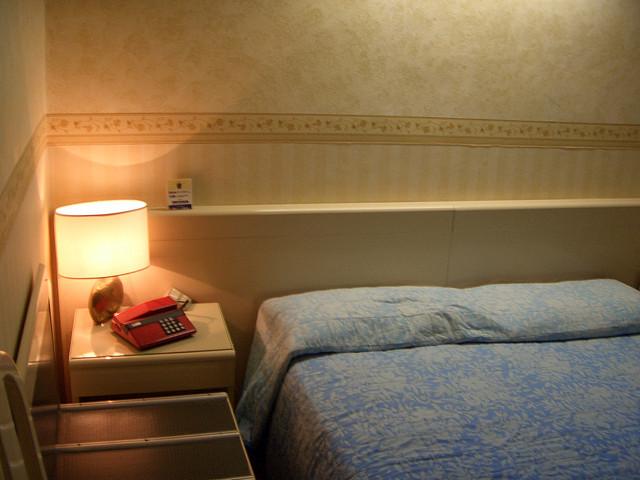Is the bed made?
Quick response, please. Yes. Is the lamp on?
Keep it brief. Yes. What color is the phone?
Write a very short answer. Red. 